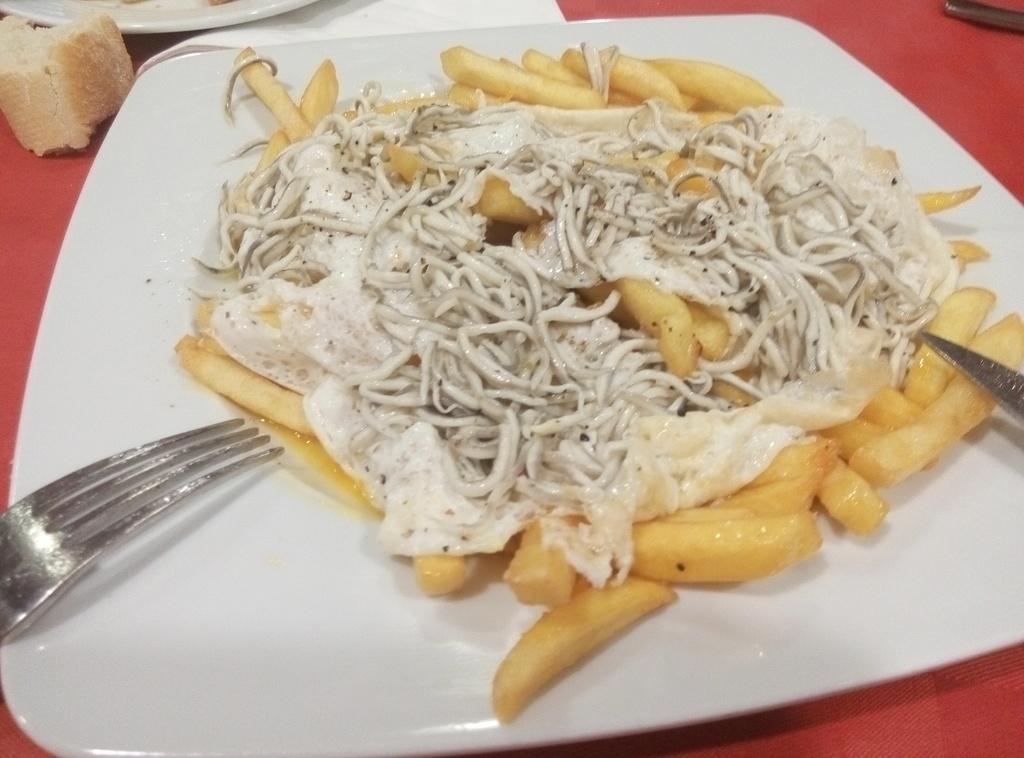In one or two sentences, can you explain what this image depicts? In this image I see the red surface on which there are 2 plates and on this plate I see food which is of yellow and white in color and I see a fork over here. 